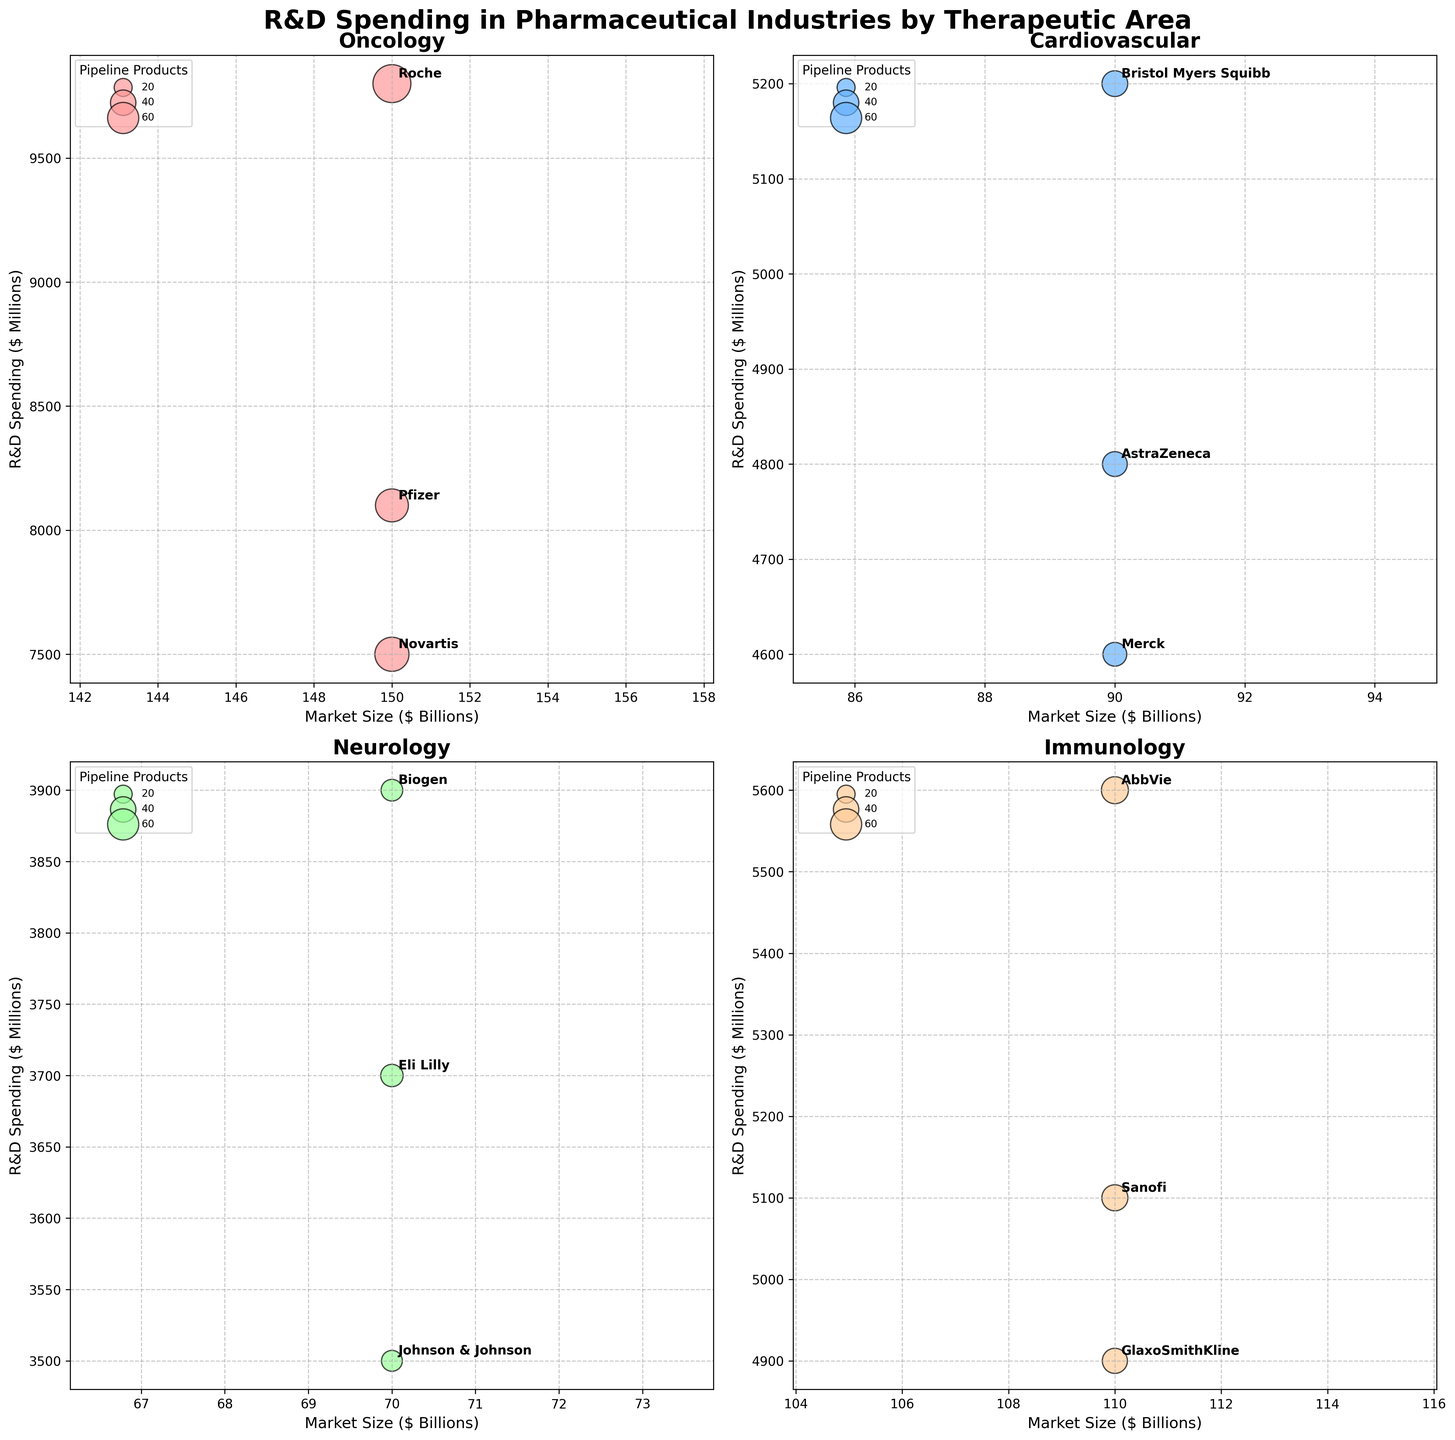What is the title of the figure? The title is displayed at the top of the figure in large, bold font. It helps to identify the overall theme of the figure.
Answer: R&D Spending in Pharmaceutical Industries by Therapeutic Area Which therapeutic area has the company with the highest R&D spending? Check each subplot and identify the highest R&D spending for each therapeutic area, then compare them. The Oncology subplot contains the highest R&D spending, shown by the largest bubble and the highest position along the Y-axis.
Answer: Oncology Which company in the Immunology therapeutic area has the most pipeline products? Inspect the Immunology subplot and find the company with the largest bubble size, as bubble size represents the number of pipeline products.
Answer: AbbVie What is the combined market size of the Neurology and Cardiovascular therapeutic areas? Locate the market sizes for each therapeutic area in their respective subplots. Cardiovascular has a market size of $90 billion, and Neurology has $70 billion. Summing them together gives $90 billion + $70 billion.
Answer: $160 billion Which company has the smallest number of pipeline products in the Infectious Diseases therapeutic area? Look at the Infectious Diseases subplot and find the company with the smallest bubble size, which indicates the fewest pipeline products.
Answer: Moderna Compare the R&D spending of Pfizer and Novartis in the Oncology therapeutic area. In the Oncology subplot, find the Y-axis values for Pfizer and Novartis. Pfizer has an R&D spending of $8100 million, and Novartis has $7500 million.
Answer: Pfizer spends more than Novartis What is the average R&D spending for companies in the Cardiovascular therapeutic area? Identify the R&D spending values in the Cardiovascular subplot for Bristol Myers Squibb ($5200 million), AstraZeneca ($4800 million), and Merck ($4600 million). Calculate the average: (5200 + 4800 + 4600) / 3.
Answer: $4867 million How many therapeutic areas does Gilead Sciences appear in? Check the labels in all subplots for Gilead Sciences. It appears only once in the Infectious Diseases subplot.
Answer: 1 Which bubble represents Roche in the Oncology therapeutic area? Locate the Oncology subplot and find the largest bubble since Roche has the highest R&D spending and number of pipeline products in this area.
Answer: The largest bubble What is the bubble color used for the Cardiovascular therapeutic area? Observe the color used consistently across the Cardiovascular subplot to differentiate it.
Answer: Blue 